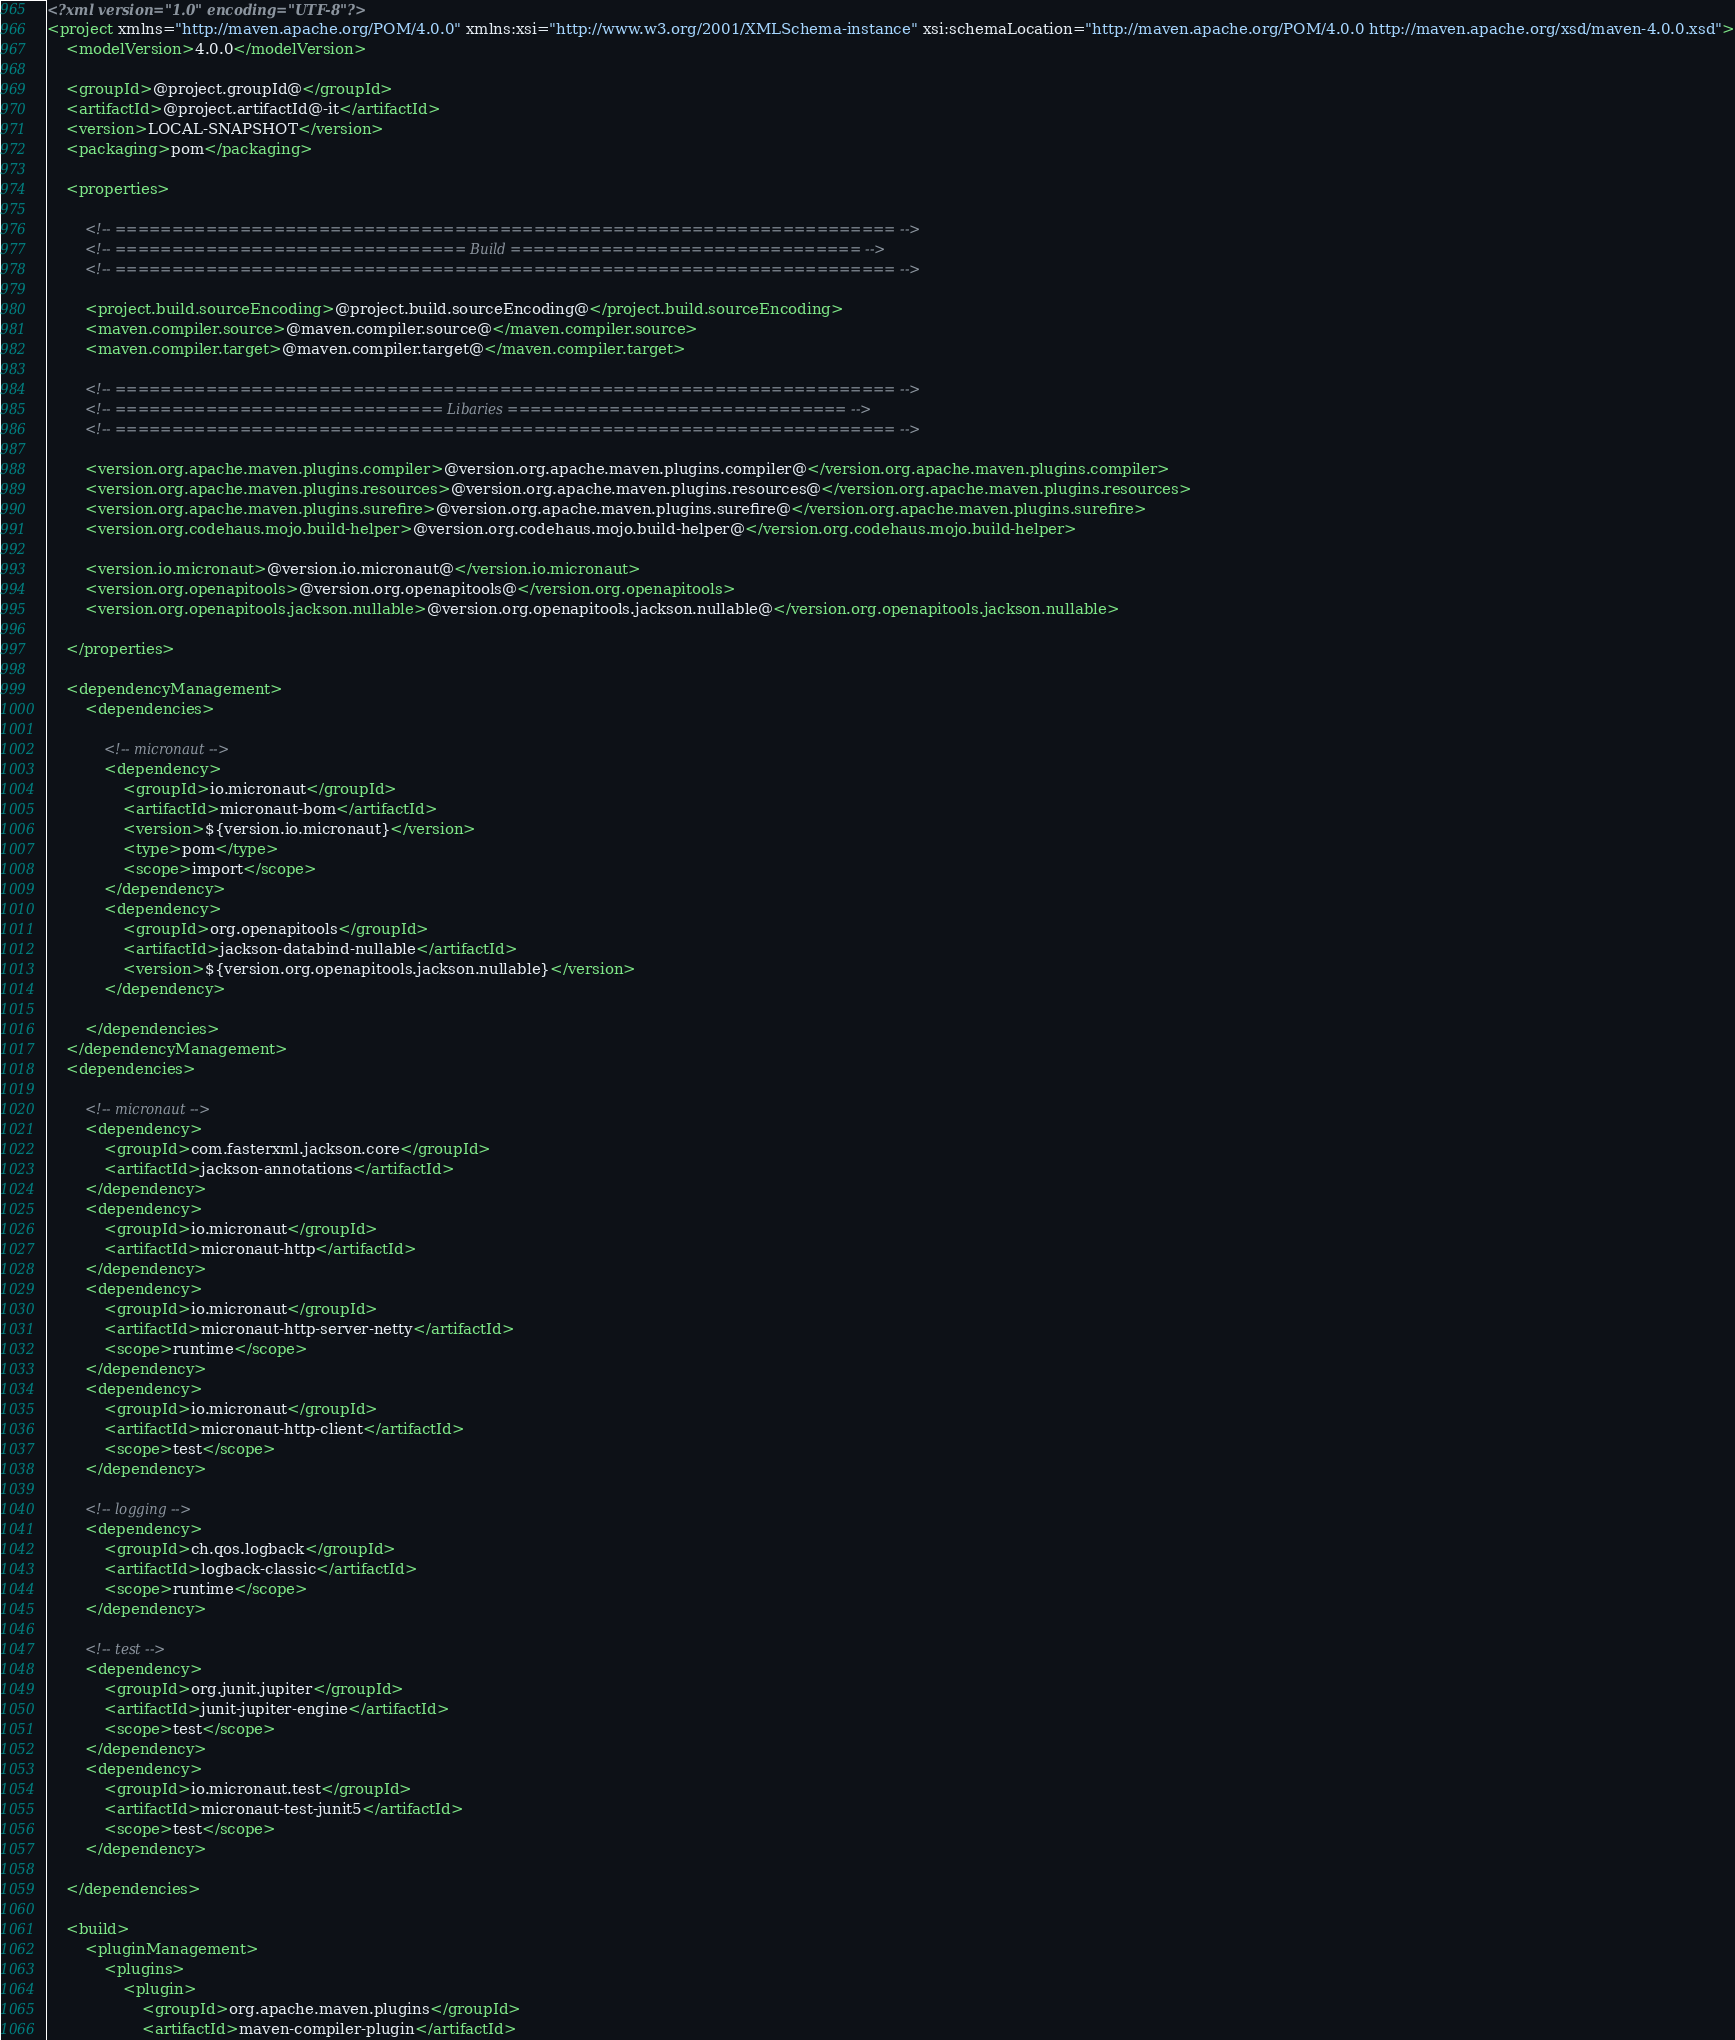Convert code to text. <code><loc_0><loc_0><loc_500><loc_500><_XML_><?xml version="1.0" encoding="UTF-8"?>
<project xmlns="http://maven.apache.org/POM/4.0.0" xmlns:xsi="http://www.w3.org/2001/XMLSchema-instance" xsi:schemaLocation="http://maven.apache.org/POM/4.0.0 http://maven.apache.org/xsd/maven-4.0.0.xsd">
	<modelVersion>4.0.0</modelVersion>

	<groupId>@project.groupId@</groupId>
	<artifactId>@project.artifactId@-it</artifactId>
	<version>LOCAL-SNAPSHOT</version>
	<packaging>pom</packaging>

	<properties>

		<!-- ===================================================================== -->
		<!-- =============================== Build =============================== -->
		<!-- ===================================================================== -->

		<project.build.sourceEncoding>@project.build.sourceEncoding@</project.build.sourceEncoding>
		<maven.compiler.source>@maven.compiler.source@</maven.compiler.source>
		<maven.compiler.target>@maven.compiler.target@</maven.compiler.target>

		<!-- ===================================================================== -->
		<!-- ============================= Libaries ============================== -->
		<!-- ===================================================================== -->

		<version.org.apache.maven.plugins.compiler>@version.org.apache.maven.plugins.compiler@</version.org.apache.maven.plugins.compiler>
		<version.org.apache.maven.plugins.resources>@version.org.apache.maven.plugins.resources@</version.org.apache.maven.plugins.resources>
		<version.org.apache.maven.plugins.surefire>@version.org.apache.maven.plugins.surefire@</version.org.apache.maven.plugins.surefire>
		<version.org.codehaus.mojo.build-helper>@version.org.codehaus.mojo.build-helper@</version.org.codehaus.mojo.build-helper>

		<version.io.micronaut>@version.io.micronaut@</version.io.micronaut>
		<version.org.openapitools>@version.org.openapitools@</version.org.openapitools>
		<version.org.openapitools.jackson.nullable>@version.org.openapitools.jackson.nullable@</version.org.openapitools.jackson.nullable>

	</properties>

	<dependencyManagement>
		<dependencies>

			<!-- micronaut -->
			<dependency>
				<groupId>io.micronaut</groupId>
				<artifactId>micronaut-bom</artifactId>
				<version>${version.io.micronaut}</version>
				<type>pom</type>
				<scope>import</scope>
			</dependency>
			<dependency>
				<groupId>org.openapitools</groupId>
				<artifactId>jackson-databind-nullable</artifactId>
				<version>${version.org.openapitools.jackson.nullable}</version>
			</dependency>

		</dependencies>
	</dependencyManagement>
	<dependencies>

		<!-- micronaut -->
		<dependency>
			<groupId>com.fasterxml.jackson.core</groupId>
			<artifactId>jackson-annotations</artifactId>
		</dependency>
		<dependency>
			<groupId>io.micronaut</groupId>
			<artifactId>micronaut-http</artifactId>
		</dependency>
		<dependency>
			<groupId>io.micronaut</groupId>
			<artifactId>micronaut-http-server-netty</artifactId>
			<scope>runtime</scope>
		</dependency>
		<dependency>
			<groupId>io.micronaut</groupId>
			<artifactId>micronaut-http-client</artifactId>
			<scope>test</scope>
		</dependency>

		<!-- logging -->
		<dependency>
			<groupId>ch.qos.logback</groupId>
			<artifactId>logback-classic</artifactId>
			<scope>runtime</scope>
		</dependency>

		<!-- test -->
		<dependency>
			<groupId>org.junit.jupiter</groupId>
			<artifactId>junit-jupiter-engine</artifactId>
			<scope>test</scope>
		</dependency>
		<dependency>
			<groupId>io.micronaut.test</groupId>
			<artifactId>micronaut-test-junit5</artifactId>
			<scope>test</scope>
		</dependency>

	</dependencies>

	<build>
		<pluginManagement>
			<plugins>
				<plugin>
					<groupId>org.apache.maven.plugins</groupId>
					<artifactId>maven-compiler-plugin</artifactId></code> 